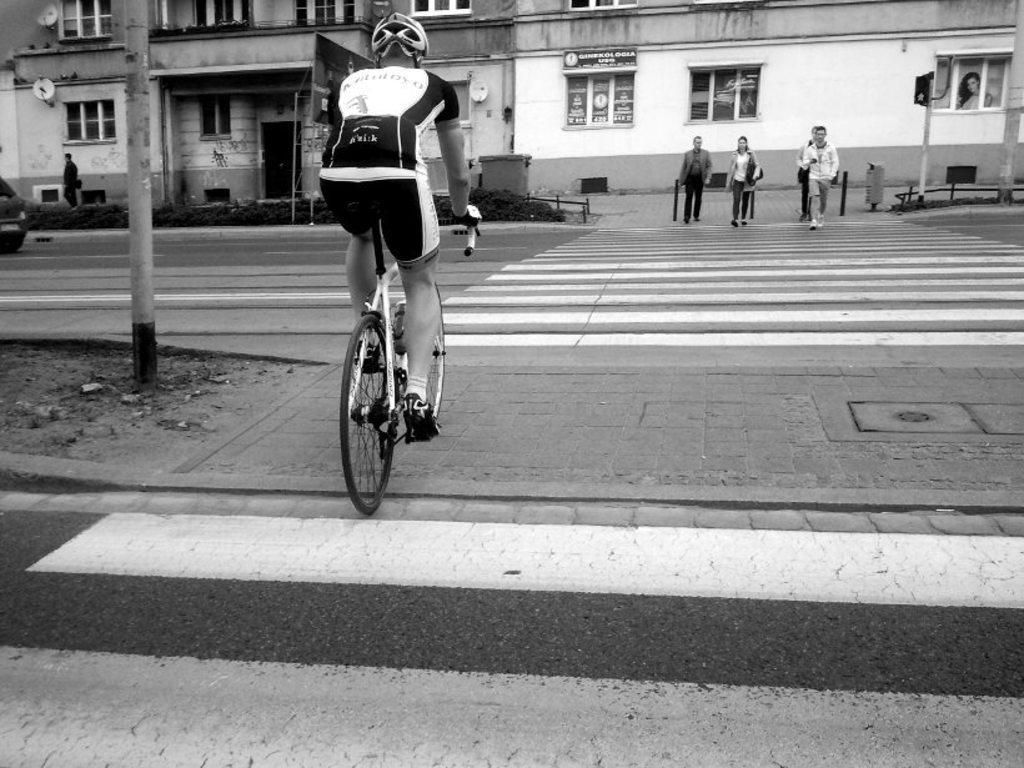Could you give a brief overview of what you see in this image? A man is riding bicycle on the road. In the background there are buildings,pole,vehicle,plants,windows and few people crossing the road. 